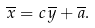<formula> <loc_0><loc_0><loc_500><loc_500>\overline { x } = c \, \overline { y } + \overline { a } .</formula> 